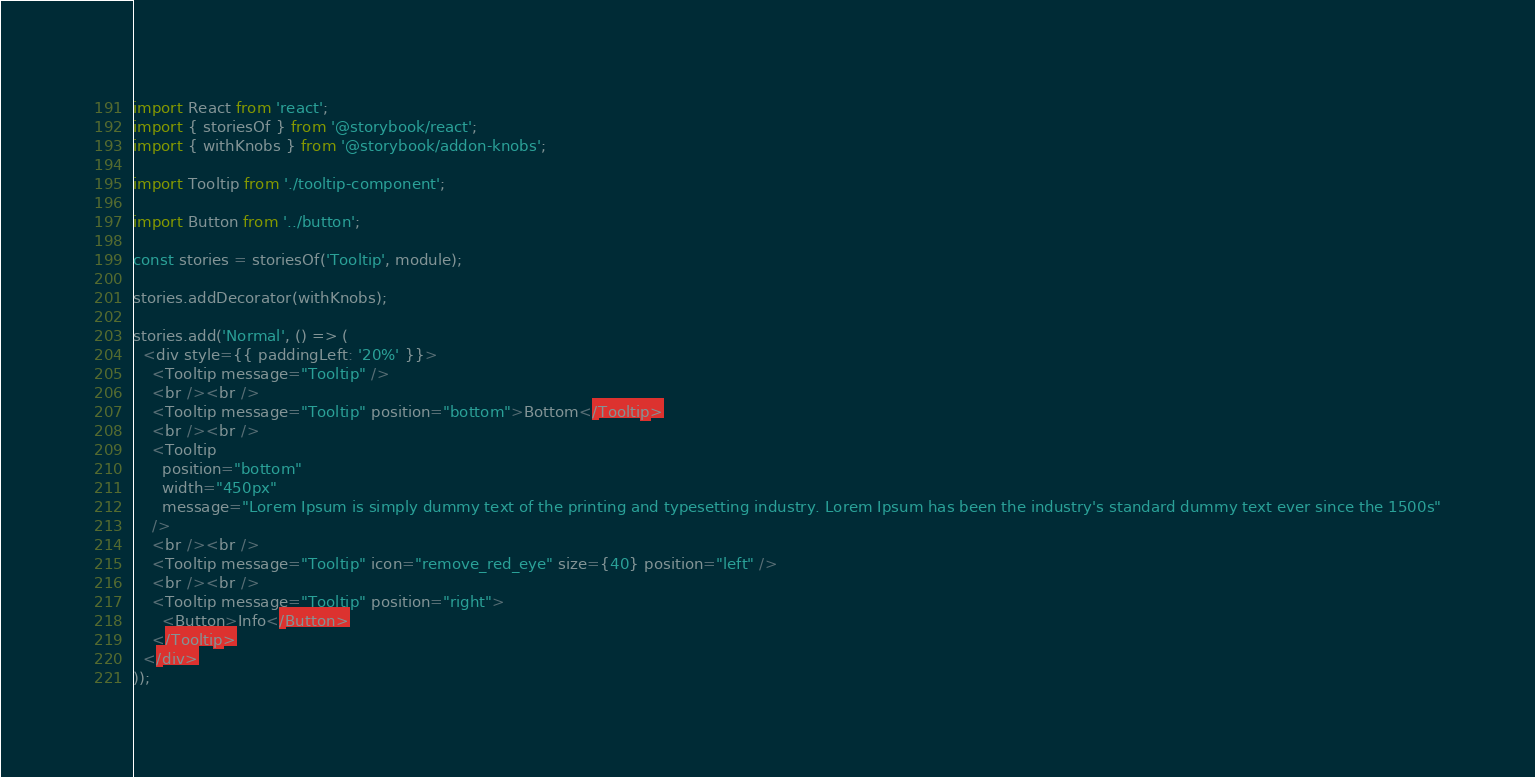Convert code to text. <code><loc_0><loc_0><loc_500><loc_500><_JavaScript_>import React from 'react';
import { storiesOf } from '@storybook/react';
import { withKnobs } from '@storybook/addon-knobs';

import Tooltip from './tooltip-component';

import Button from '../button';

const stories = storiesOf('Tooltip', module);

stories.addDecorator(withKnobs);

stories.add('Normal', () => (
  <div style={{ paddingLeft: '20%' }}>
    <Tooltip message="Tooltip" />
    <br /><br />
    <Tooltip message="Tooltip" position="bottom">Bottom</Tooltip>
    <br /><br />
    <Tooltip
      position="bottom"
      width="450px"
      message="Lorem Ipsum is simply dummy text of the printing and typesetting industry. Lorem Ipsum has been the industry's standard dummy text ever since the 1500s"
    />
    <br /><br />
    <Tooltip message="Tooltip" icon="remove_red_eye" size={40} position="left" />
    <br /><br />
    <Tooltip message="Tooltip" position="right">
      <Button>Info</Button>
    </Tooltip>
  </div>
));
</code> 